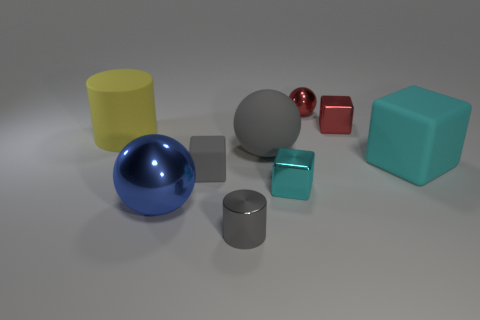What number of other objects are there of the same color as the small shiny cylinder? 2 